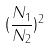Convert formula to latex. <formula><loc_0><loc_0><loc_500><loc_500>( \frac { N _ { 1 } } { N _ { 2 } } ) ^ { 2 }</formula> 